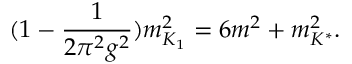Convert formula to latex. <formula><loc_0><loc_0><loc_500><loc_500>( 1 - { \frac { 1 } { 2 \pi ^ { 2 } g ^ { 2 } } } ) m _ { K _ { 1 } } ^ { 2 } = 6 m ^ { 2 } + m _ { K ^ { * } } ^ { 2 } .</formula> 